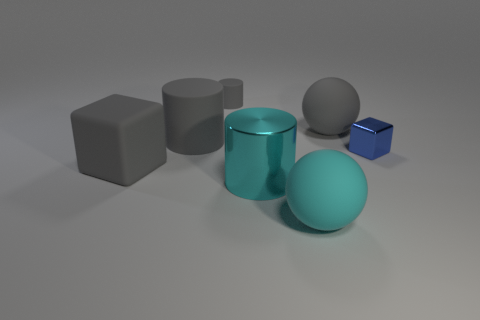Subtract all red blocks. Subtract all red cylinders. How many blocks are left? 2 Add 2 large rubber spheres. How many objects exist? 9 Subtract all cylinders. How many objects are left? 4 Subtract all tiny red shiny blocks. Subtract all small rubber objects. How many objects are left? 6 Add 5 large gray matte spheres. How many large gray matte spheres are left? 6 Add 3 large matte blocks. How many large matte blocks exist? 4 Subtract 0 red spheres. How many objects are left? 7 